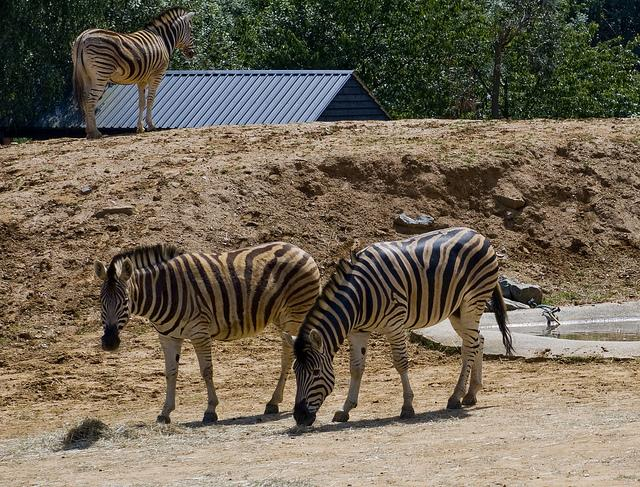How many zebras are walking around on top of the dirt in the courtyard?

Choices:
A) three
B) five
C) one
D) two three 